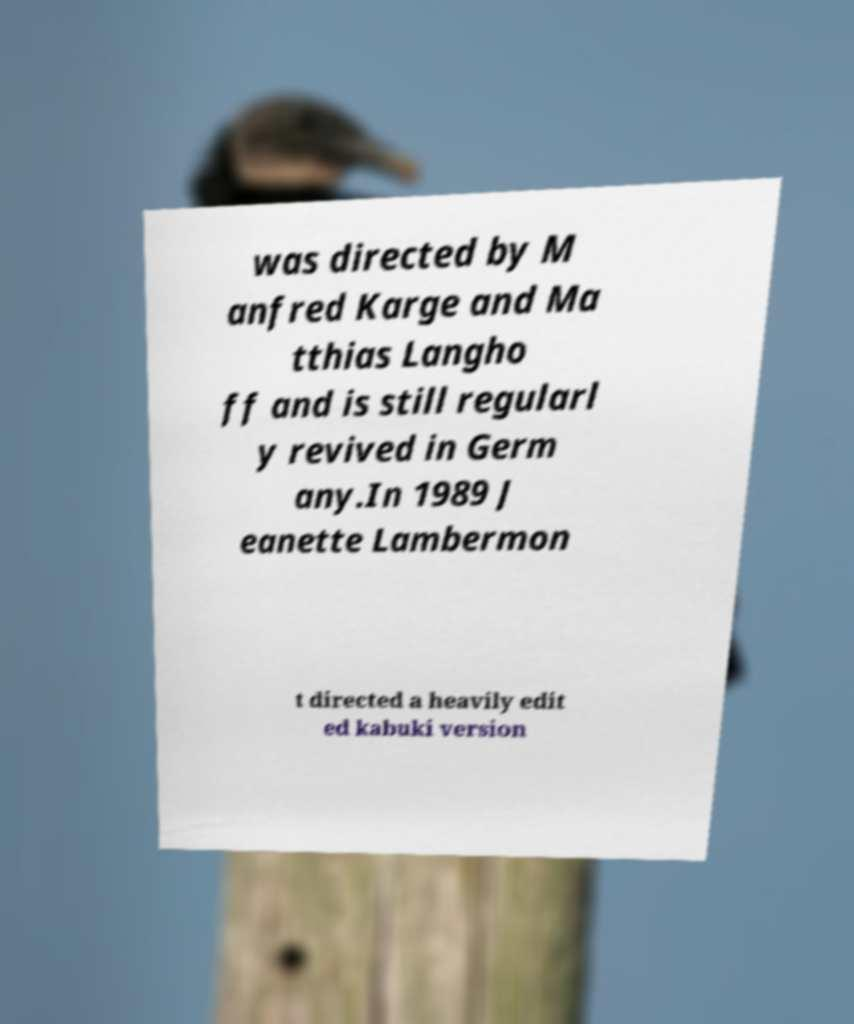Please read and relay the text visible in this image. What does it say? was directed by M anfred Karge and Ma tthias Langho ff and is still regularl y revived in Germ any.In 1989 J eanette Lambermon t directed a heavily edit ed kabuki version 